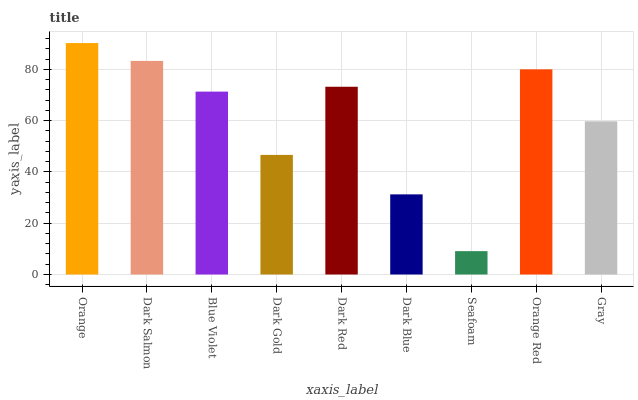Is Seafoam the minimum?
Answer yes or no. Yes. Is Orange the maximum?
Answer yes or no. Yes. Is Dark Salmon the minimum?
Answer yes or no. No. Is Dark Salmon the maximum?
Answer yes or no. No. Is Orange greater than Dark Salmon?
Answer yes or no. Yes. Is Dark Salmon less than Orange?
Answer yes or no. Yes. Is Dark Salmon greater than Orange?
Answer yes or no. No. Is Orange less than Dark Salmon?
Answer yes or no. No. Is Blue Violet the high median?
Answer yes or no. Yes. Is Blue Violet the low median?
Answer yes or no. Yes. Is Dark Red the high median?
Answer yes or no. No. Is Dark Red the low median?
Answer yes or no. No. 